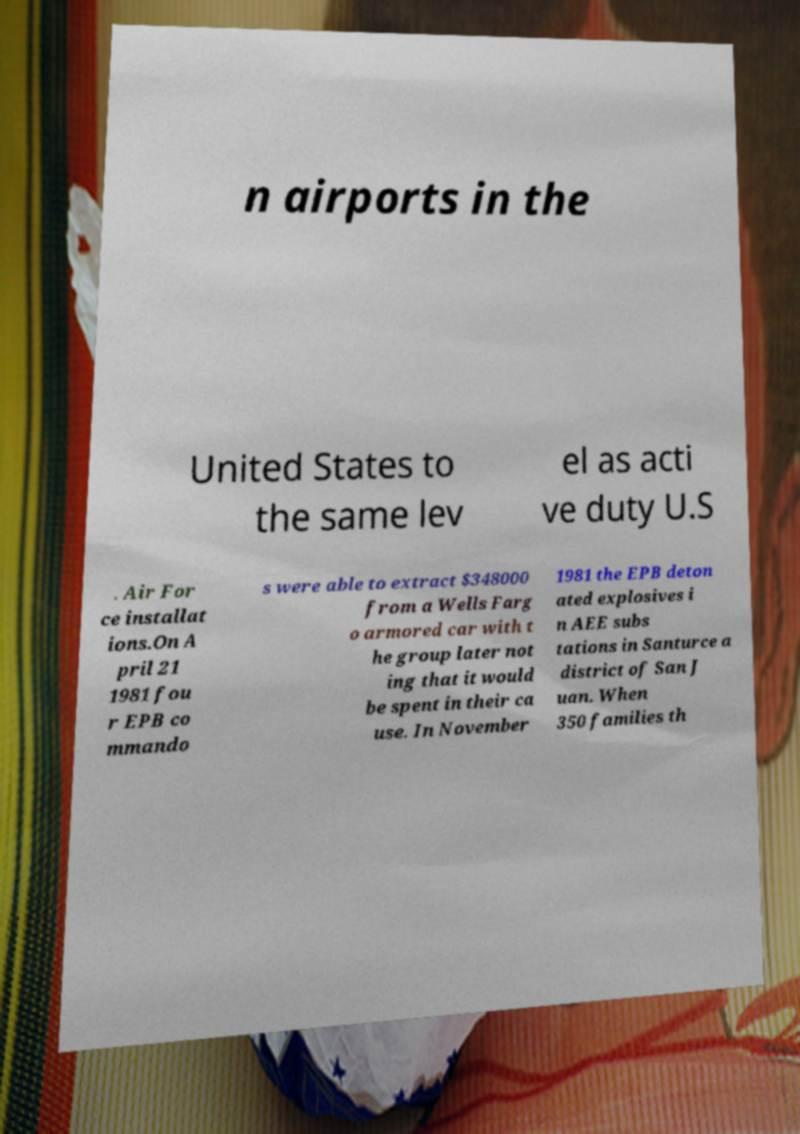Please identify and transcribe the text found in this image. n airports in the United States to the same lev el as acti ve duty U.S . Air For ce installat ions.On A pril 21 1981 fou r EPB co mmando s were able to extract $348000 from a Wells Farg o armored car with t he group later not ing that it would be spent in their ca use. In November 1981 the EPB deton ated explosives i n AEE subs tations in Santurce a district of San J uan. When 350 families th 